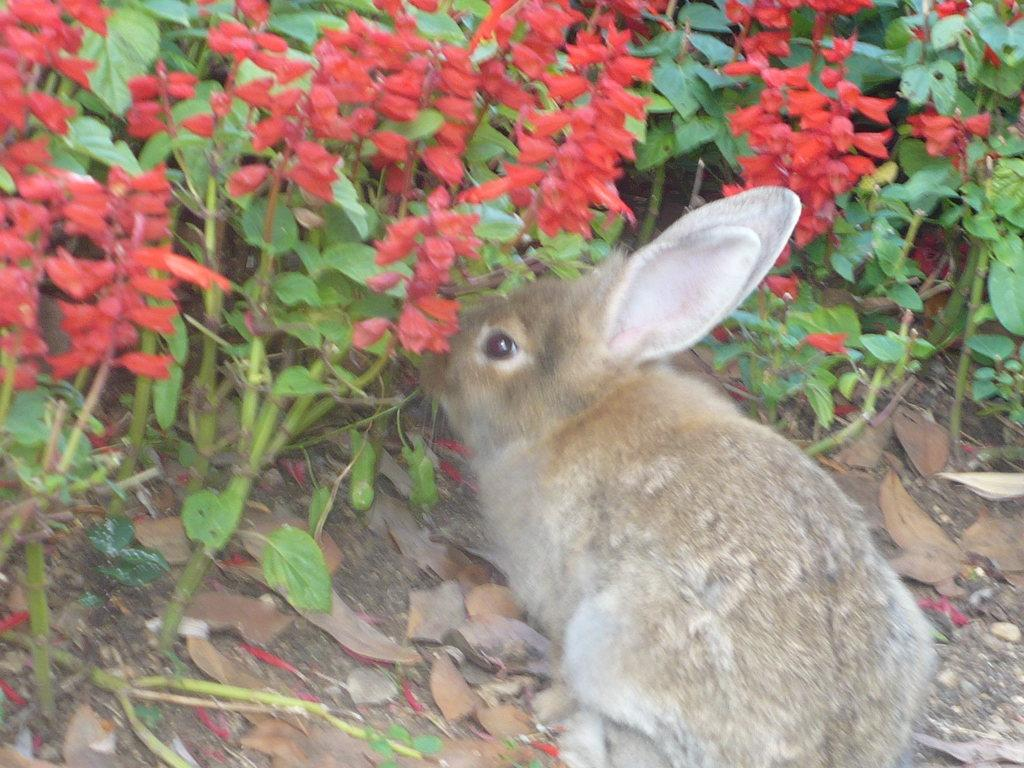What type of animal is present in the image? There is a rabbit in the image. What other elements can be seen in the image besides the rabbit? There are plants with flowers in the image. How many hands are visible in the image? There are no hands visible in the image. Are there any gloves present in the image? There are no gloves present in the image. 